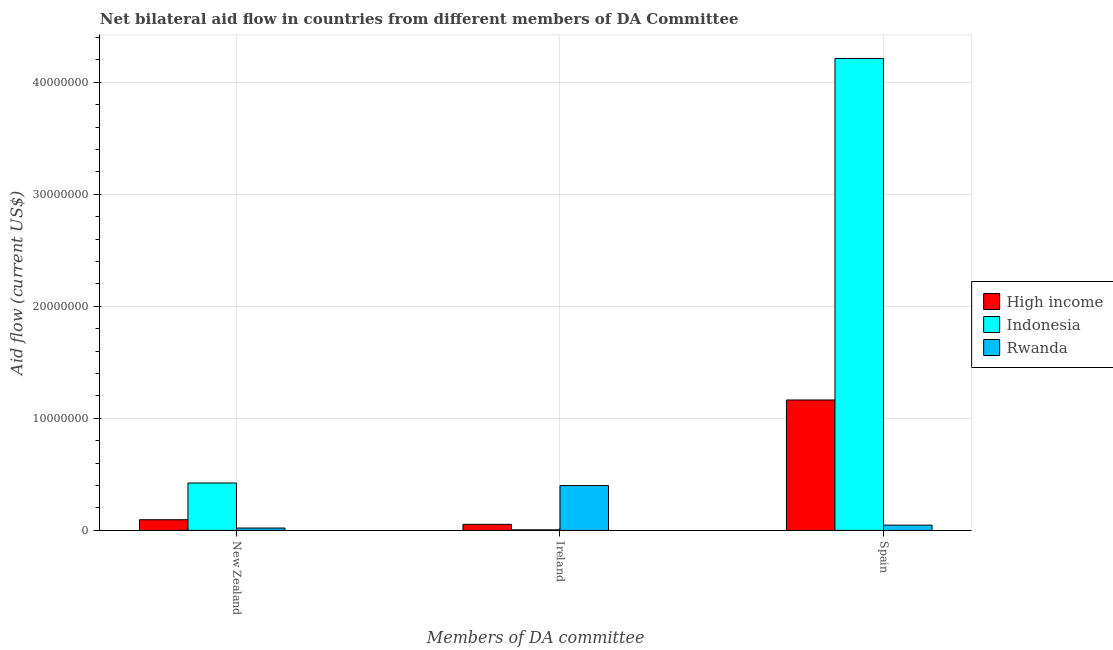Are the number of bars on each tick of the X-axis equal?
Provide a short and direct response. Yes. What is the label of the 1st group of bars from the left?
Your response must be concise. New Zealand. What is the amount of aid provided by new zealand in Indonesia?
Give a very brief answer. 4.23e+06. Across all countries, what is the maximum amount of aid provided by ireland?
Provide a succinct answer. 4.00e+06. Across all countries, what is the minimum amount of aid provided by spain?
Provide a succinct answer. 4.70e+05. What is the total amount of aid provided by ireland in the graph?
Your response must be concise. 4.59e+06. What is the difference between the amount of aid provided by new zealand in Indonesia and that in High income?
Offer a very short reply. 3.28e+06. What is the difference between the amount of aid provided by ireland in Rwanda and the amount of aid provided by new zealand in Indonesia?
Make the answer very short. -2.30e+05. What is the average amount of aid provided by ireland per country?
Your answer should be compact. 1.53e+06. What is the difference between the amount of aid provided by new zealand and amount of aid provided by spain in High income?
Your response must be concise. -1.07e+07. What is the ratio of the amount of aid provided by new zealand in Indonesia to that in High income?
Provide a succinct answer. 4.45. Is the amount of aid provided by spain in Indonesia less than that in High income?
Make the answer very short. No. Is the difference between the amount of aid provided by ireland in Indonesia and Rwanda greater than the difference between the amount of aid provided by spain in Indonesia and Rwanda?
Your answer should be compact. No. What is the difference between the highest and the second highest amount of aid provided by new zealand?
Ensure brevity in your answer.  3.28e+06. What is the difference between the highest and the lowest amount of aid provided by ireland?
Ensure brevity in your answer.  3.95e+06. In how many countries, is the amount of aid provided by new zealand greater than the average amount of aid provided by new zealand taken over all countries?
Provide a succinct answer. 1. What does the 3rd bar from the left in Ireland represents?
Give a very brief answer. Rwanda. Is it the case that in every country, the sum of the amount of aid provided by new zealand and amount of aid provided by ireland is greater than the amount of aid provided by spain?
Ensure brevity in your answer.  No. How many bars are there?
Ensure brevity in your answer.  9. Are all the bars in the graph horizontal?
Your response must be concise. No. What is the difference between two consecutive major ticks on the Y-axis?
Your answer should be compact. 1.00e+07. Where does the legend appear in the graph?
Keep it short and to the point. Center right. How many legend labels are there?
Make the answer very short. 3. What is the title of the graph?
Provide a short and direct response. Net bilateral aid flow in countries from different members of DA Committee. What is the label or title of the X-axis?
Keep it short and to the point. Members of DA committee. What is the Aid flow (current US$) in High income in New Zealand?
Your answer should be very brief. 9.50e+05. What is the Aid flow (current US$) in Indonesia in New Zealand?
Ensure brevity in your answer.  4.23e+06. What is the Aid flow (current US$) in Rwanda in New Zealand?
Offer a terse response. 2.10e+05. What is the Aid flow (current US$) of High income in Ireland?
Provide a succinct answer. 5.40e+05. What is the Aid flow (current US$) of High income in Spain?
Your answer should be very brief. 1.16e+07. What is the Aid flow (current US$) of Indonesia in Spain?
Offer a terse response. 4.21e+07. Across all Members of DA committee, what is the maximum Aid flow (current US$) in High income?
Your answer should be very brief. 1.16e+07. Across all Members of DA committee, what is the maximum Aid flow (current US$) in Indonesia?
Give a very brief answer. 4.21e+07. Across all Members of DA committee, what is the maximum Aid flow (current US$) of Rwanda?
Your answer should be very brief. 4.00e+06. Across all Members of DA committee, what is the minimum Aid flow (current US$) in High income?
Keep it short and to the point. 5.40e+05. Across all Members of DA committee, what is the minimum Aid flow (current US$) in Indonesia?
Make the answer very short. 5.00e+04. What is the total Aid flow (current US$) in High income in the graph?
Keep it short and to the point. 1.31e+07. What is the total Aid flow (current US$) of Indonesia in the graph?
Keep it short and to the point. 4.64e+07. What is the total Aid flow (current US$) of Rwanda in the graph?
Your response must be concise. 4.68e+06. What is the difference between the Aid flow (current US$) in Indonesia in New Zealand and that in Ireland?
Your response must be concise. 4.18e+06. What is the difference between the Aid flow (current US$) in Rwanda in New Zealand and that in Ireland?
Ensure brevity in your answer.  -3.79e+06. What is the difference between the Aid flow (current US$) of High income in New Zealand and that in Spain?
Ensure brevity in your answer.  -1.07e+07. What is the difference between the Aid flow (current US$) of Indonesia in New Zealand and that in Spain?
Make the answer very short. -3.79e+07. What is the difference between the Aid flow (current US$) in High income in Ireland and that in Spain?
Offer a terse response. -1.11e+07. What is the difference between the Aid flow (current US$) in Indonesia in Ireland and that in Spain?
Ensure brevity in your answer.  -4.21e+07. What is the difference between the Aid flow (current US$) in Rwanda in Ireland and that in Spain?
Offer a very short reply. 3.53e+06. What is the difference between the Aid flow (current US$) in High income in New Zealand and the Aid flow (current US$) in Rwanda in Ireland?
Your answer should be very brief. -3.05e+06. What is the difference between the Aid flow (current US$) in High income in New Zealand and the Aid flow (current US$) in Indonesia in Spain?
Your answer should be very brief. -4.12e+07. What is the difference between the Aid flow (current US$) of Indonesia in New Zealand and the Aid flow (current US$) of Rwanda in Spain?
Offer a terse response. 3.76e+06. What is the difference between the Aid flow (current US$) in High income in Ireland and the Aid flow (current US$) in Indonesia in Spain?
Give a very brief answer. -4.16e+07. What is the difference between the Aid flow (current US$) of Indonesia in Ireland and the Aid flow (current US$) of Rwanda in Spain?
Give a very brief answer. -4.20e+05. What is the average Aid flow (current US$) in High income per Members of DA committee?
Offer a very short reply. 4.38e+06. What is the average Aid flow (current US$) in Indonesia per Members of DA committee?
Make the answer very short. 1.55e+07. What is the average Aid flow (current US$) in Rwanda per Members of DA committee?
Offer a very short reply. 1.56e+06. What is the difference between the Aid flow (current US$) of High income and Aid flow (current US$) of Indonesia in New Zealand?
Your answer should be compact. -3.28e+06. What is the difference between the Aid flow (current US$) in High income and Aid flow (current US$) in Rwanda in New Zealand?
Give a very brief answer. 7.40e+05. What is the difference between the Aid flow (current US$) of Indonesia and Aid flow (current US$) of Rwanda in New Zealand?
Provide a succinct answer. 4.02e+06. What is the difference between the Aid flow (current US$) of High income and Aid flow (current US$) of Rwanda in Ireland?
Make the answer very short. -3.46e+06. What is the difference between the Aid flow (current US$) in Indonesia and Aid flow (current US$) in Rwanda in Ireland?
Make the answer very short. -3.95e+06. What is the difference between the Aid flow (current US$) of High income and Aid flow (current US$) of Indonesia in Spain?
Give a very brief answer. -3.05e+07. What is the difference between the Aid flow (current US$) of High income and Aid flow (current US$) of Rwanda in Spain?
Offer a terse response. 1.12e+07. What is the difference between the Aid flow (current US$) in Indonesia and Aid flow (current US$) in Rwanda in Spain?
Give a very brief answer. 4.16e+07. What is the ratio of the Aid flow (current US$) in High income in New Zealand to that in Ireland?
Your answer should be very brief. 1.76. What is the ratio of the Aid flow (current US$) in Indonesia in New Zealand to that in Ireland?
Your response must be concise. 84.6. What is the ratio of the Aid flow (current US$) of Rwanda in New Zealand to that in Ireland?
Your response must be concise. 0.05. What is the ratio of the Aid flow (current US$) of High income in New Zealand to that in Spain?
Your response must be concise. 0.08. What is the ratio of the Aid flow (current US$) in Indonesia in New Zealand to that in Spain?
Provide a short and direct response. 0.1. What is the ratio of the Aid flow (current US$) of Rwanda in New Zealand to that in Spain?
Keep it short and to the point. 0.45. What is the ratio of the Aid flow (current US$) of High income in Ireland to that in Spain?
Ensure brevity in your answer.  0.05. What is the ratio of the Aid flow (current US$) in Indonesia in Ireland to that in Spain?
Offer a very short reply. 0. What is the ratio of the Aid flow (current US$) in Rwanda in Ireland to that in Spain?
Ensure brevity in your answer.  8.51. What is the difference between the highest and the second highest Aid flow (current US$) of High income?
Make the answer very short. 1.07e+07. What is the difference between the highest and the second highest Aid flow (current US$) in Indonesia?
Provide a succinct answer. 3.79e+07. What is the difference between the highest and the second highest Aid flow (current US$) of Rwanda?
Ensure brevity in your answer.  3.53e+06. What is the difference between the highest and the lowest Aid flow (current US$) of High income?
Provide a succinct answer. 1.11e+07. What is the difference between the highest and the lowest Aid flow (current US$) in Indonesia?
Make the answer very short. 4.21e+07. What is the difference between the highest and the lowest Aid flow (current US$) of Rwanda?
Your answer should be compact. 3.79e+06. 